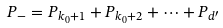<formula> <loc_0><loc_0><loc_500><loc_500>P _ { - } = P _ { k _ { 0 } + 1 } + P _ { k _ { 0 } + 2 } + \dots + P _ { d ^ { \prime } }</formula> 